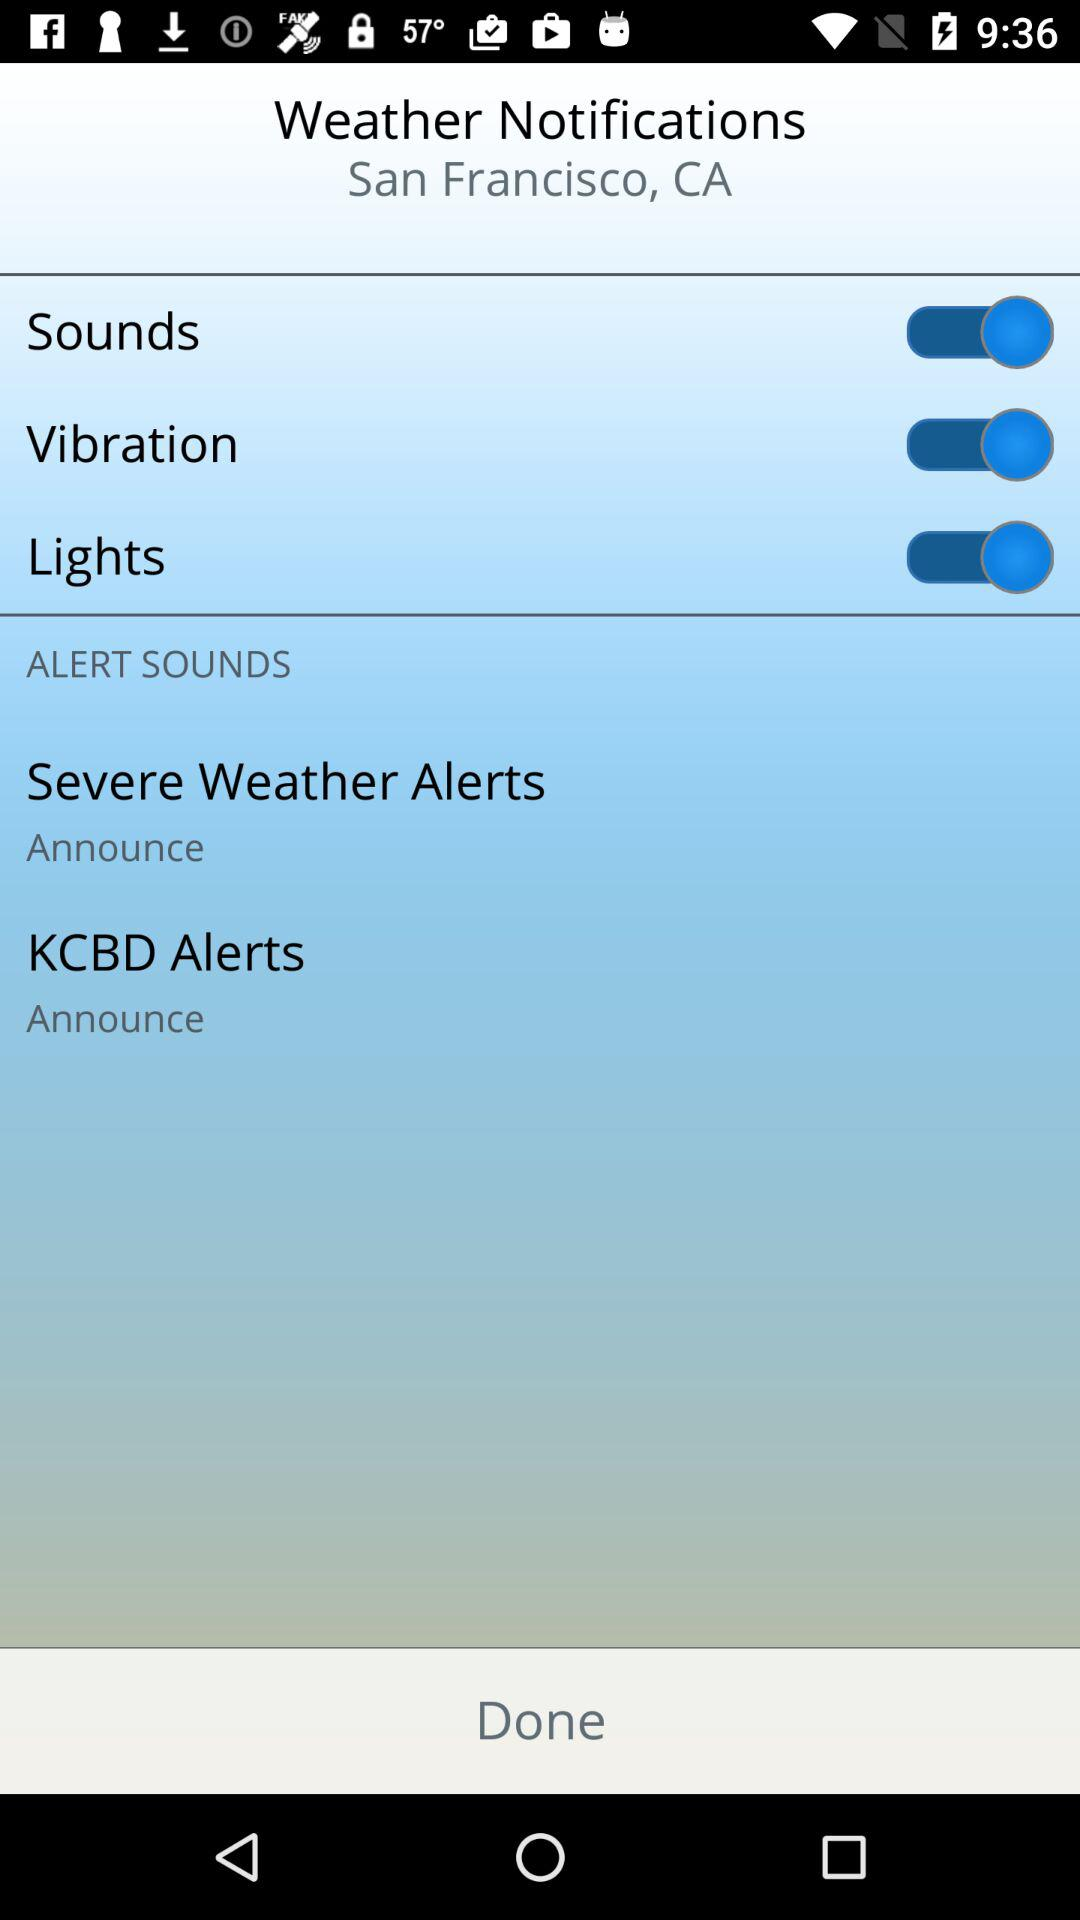What is the mentioned location? The mentioned location is San Francisco, CA. 